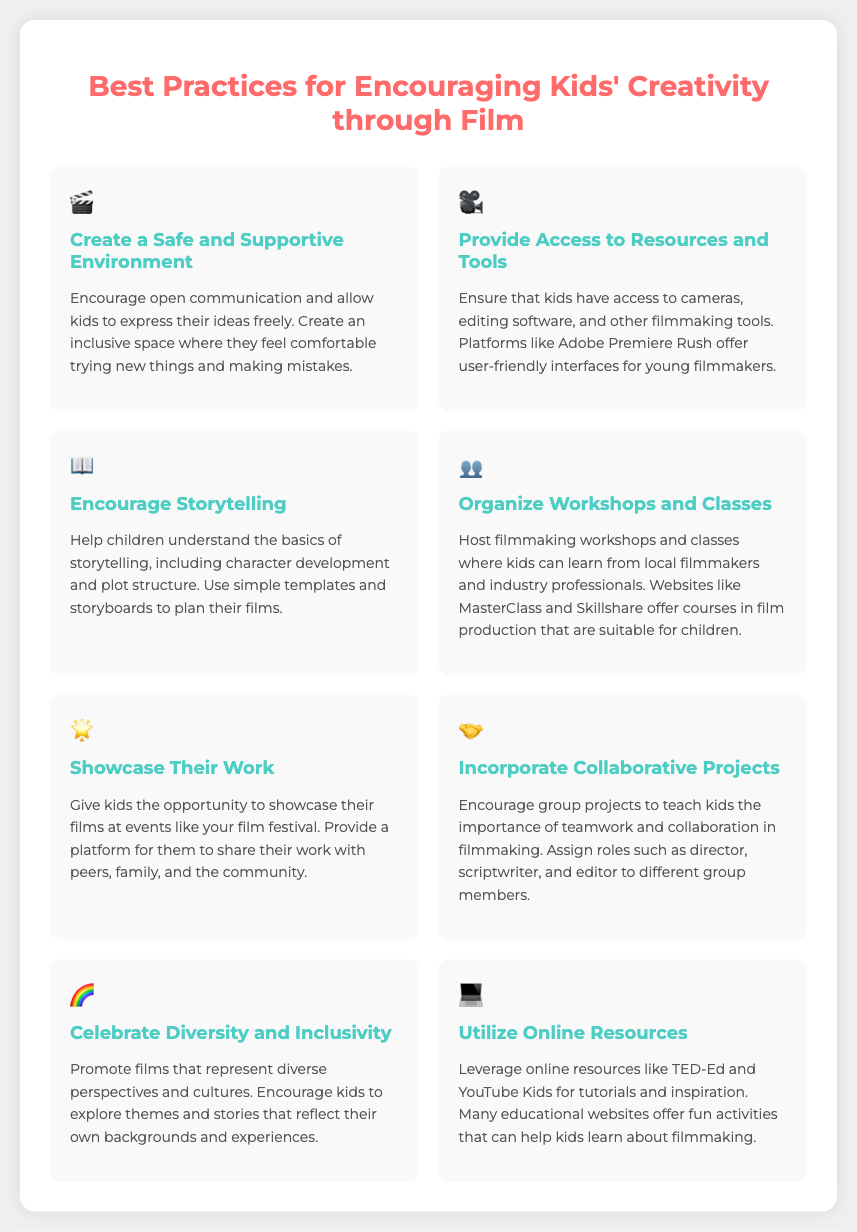what is the title of the infographic? The title is the main heading of the document, which provides insight into its content.
Answer: Best Practices for Encouraging Kids' Creativity through Film how many best practices are listed? The document enumerates several practices aimed at encouraging creativity, which can be counted directly.
Answer: 8 what icon represents storytelling? Each practice is accompanied by a unique icon, in this case, it is crucial to identify it.
Answer: 📖 what is one resource recommended for access to filmmaking tools? The document mentions specific platforms or tools that children can use for filmmaking in the context of providing resources.
Answer: Adobe Premiere Rush what is a suggested activity to teach collaboration among kids? The document describes a method of encouraging teamwork and its related activities involving children.
Answer: Group projects which practice emphasizes inclusivity? The document discusses several practices, and this one is focused on promoting representation and diversity.
Answer: Celebrate Diversity and Inclusivity what type of classes should parents organize for their kids? The infographic mentions specific kinds of educational gatherings aimed at filmmaking.
Answer: Workshops and classes which online platform is mentioned for tutorials? The document cites specific online educational platforms that can provide resources for learning about filmmaking.
Answer: TED-Ed 